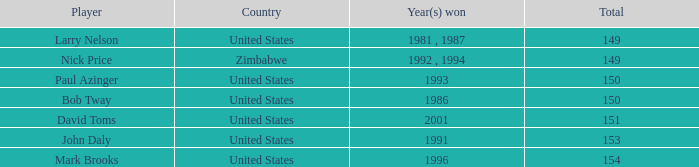How many to pars were won in 1993? 1.0. 